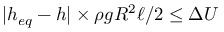Convert formula to latex. <formula><loc_0><loc_0><loc_500><loc_500>| h _ { e q } - h | \times \rho g R ^ { 2 } \ell / 2 \leq \Delta U</formula> 